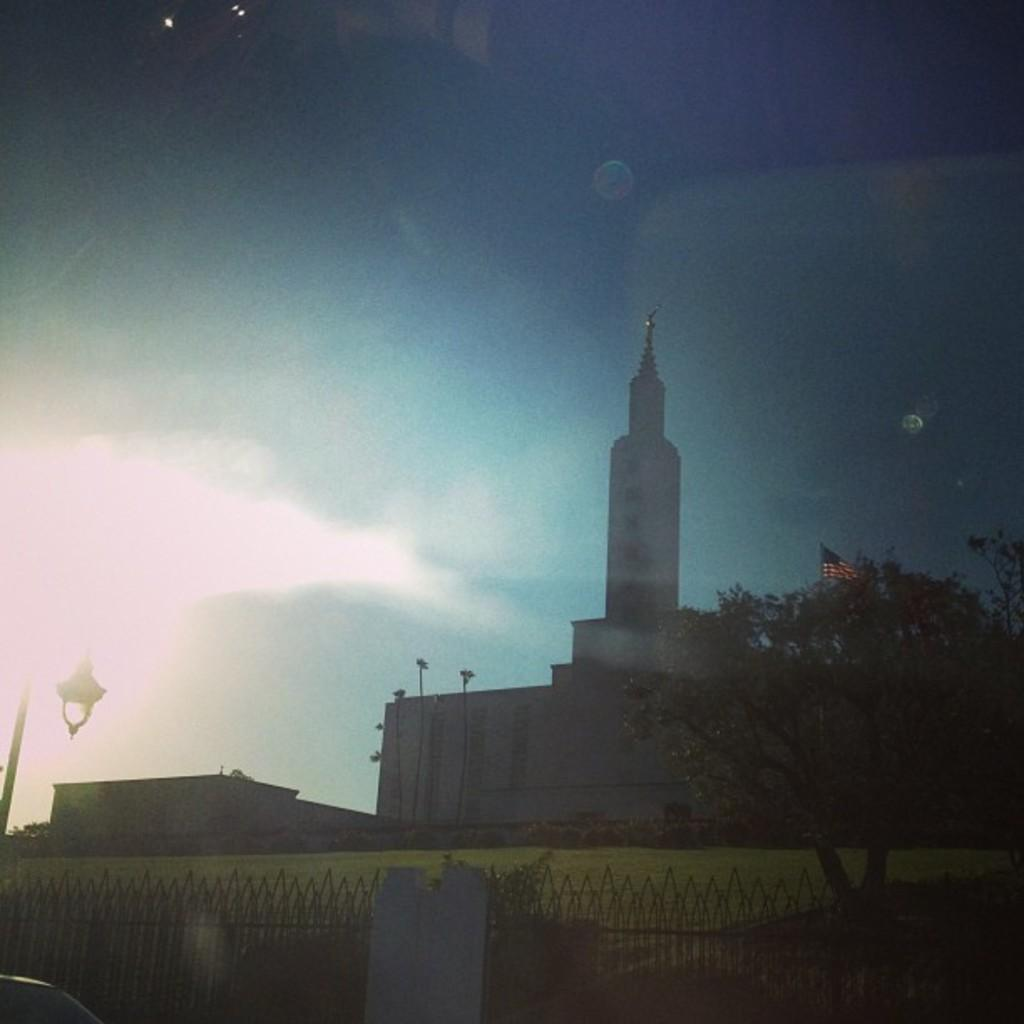What type of structures can be seen in the image? There are buildings in the image. What is attached to the pole in the image? There is a flag attached to the pole in the image. What type of vegetation is present in the image? There are trees and grass in the image. What is the purpose of the pole in the image? The pole is used to hold the flag in the image. What is the source of light in the image? There is a lamp in the image. What is used to enclose or separate areas in the image? There is a fence in the image. What is visible in the background of the image? The sky is visible in the background of the image. What type of square is depicted in the image? There is no square present in the image. What type of feast is being celebrated in the image? There is no feast or celebration depicted in the image. 